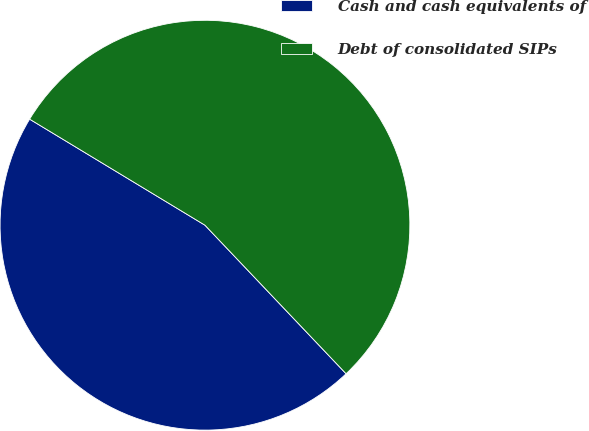Convert chart. <chart><loc_0><loc_0><loc_500><loc_500><pie_chart><fcel>Cash and cash equivalents of<fcel>Debt of consolidated SIPs<nl><fcel>45.75%<fcel>54.25%<nl></chart> 